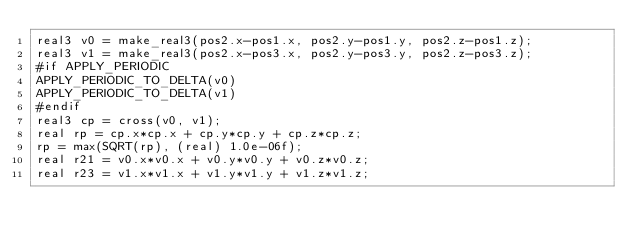Convert code to text. <code><loc_0><loc_0><loc_500><loc_500><_Cuda_>real3 v0 = make_real3(pos2.x-pos1.x, pos2.y-pos1.y, pos2.z-pos1.z);
real3 v1 = make_real3(pos2.x-pos3.x, pos2.y-pos3.y, pos2.z-pos3.z);
#if APPLY_PERIODIC
APPLY_PERIODIC_TO_DELTA(v0)
APPLY_PERIODIC_TO_DELTA(v1)
#endif
real3 cp = cross(v0, v1);
real rp = cp.x*cp.x + cp.y*cp.y + cp.z*cp.z;
rp = max(SQRT(rp), (real) 1.0e-06f);
real r21 = v0.x*v0.x + v0.y*v0.y + v0.z*v0.z;
real r23 = v1.x*v1.x + v1.y*v1.y + v1.z*v1.z;</code> 